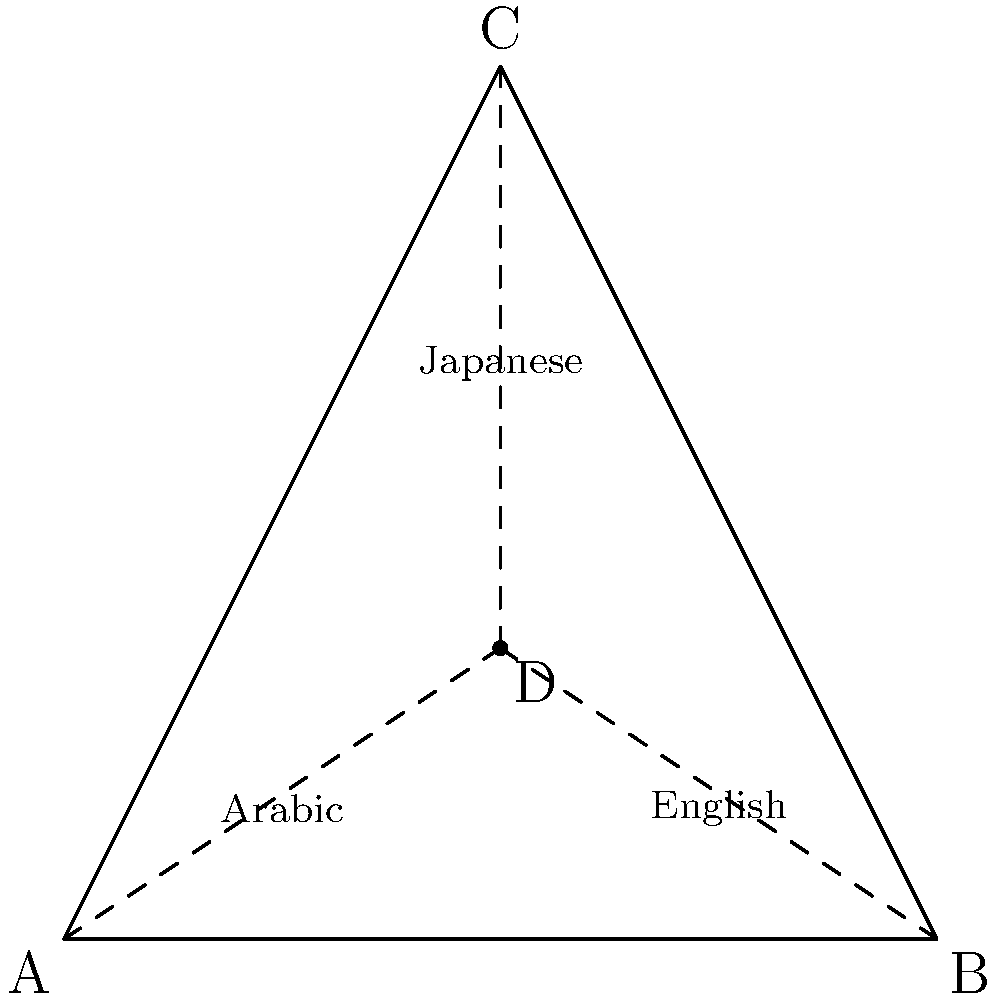In a vector-based icon design for a multilingual software application, you need to adapt the icon for Arabic, English, and Japanese versions. The icon is represented by an equilateral triangle ABC, where point D is the centroid. If the original text placement for English is at point B, and you need to maintain equal distances between text placements for all three languages, where should the text for Arabic and Japanese be positioned? To determine the correct text placement for Arabic and Japanese while maintaining equal distances, we can follow these steps:

1. Recognize that the centroid (point D) divides each median of the triangle in a 2:1 ratio.

2. The English text is placed at point B, which is one of the vertices of the triangle.

3. To maintain equal distances, we need to place the other two language texts at the other two vertices of the triangle.

4. In an equilateral triangle, all sides are equal, and all angles are 60°. This ensures that the distance between any two vertices is the same.

5. The Arabic text should be placed at point A, which is opposite to the English text (point B) and equidistant from the Japanese text.

6. The Japanese text should be placed at point C, which is at the top of the triangle and equidistant from both English (point B) and Arabic (point A) text placements.

7. This arrangement ensures that all three text placements (A, B, and C) are at the vertices of the equilateral triangle, maintaining equal distances between them.

8. The centroid (point D) remains at the center, equally distant from all three text placements, which can be useful for maintaining the icon's balance and symmetry across all language versions.
Answer: Arabic at A, Japanese at C 